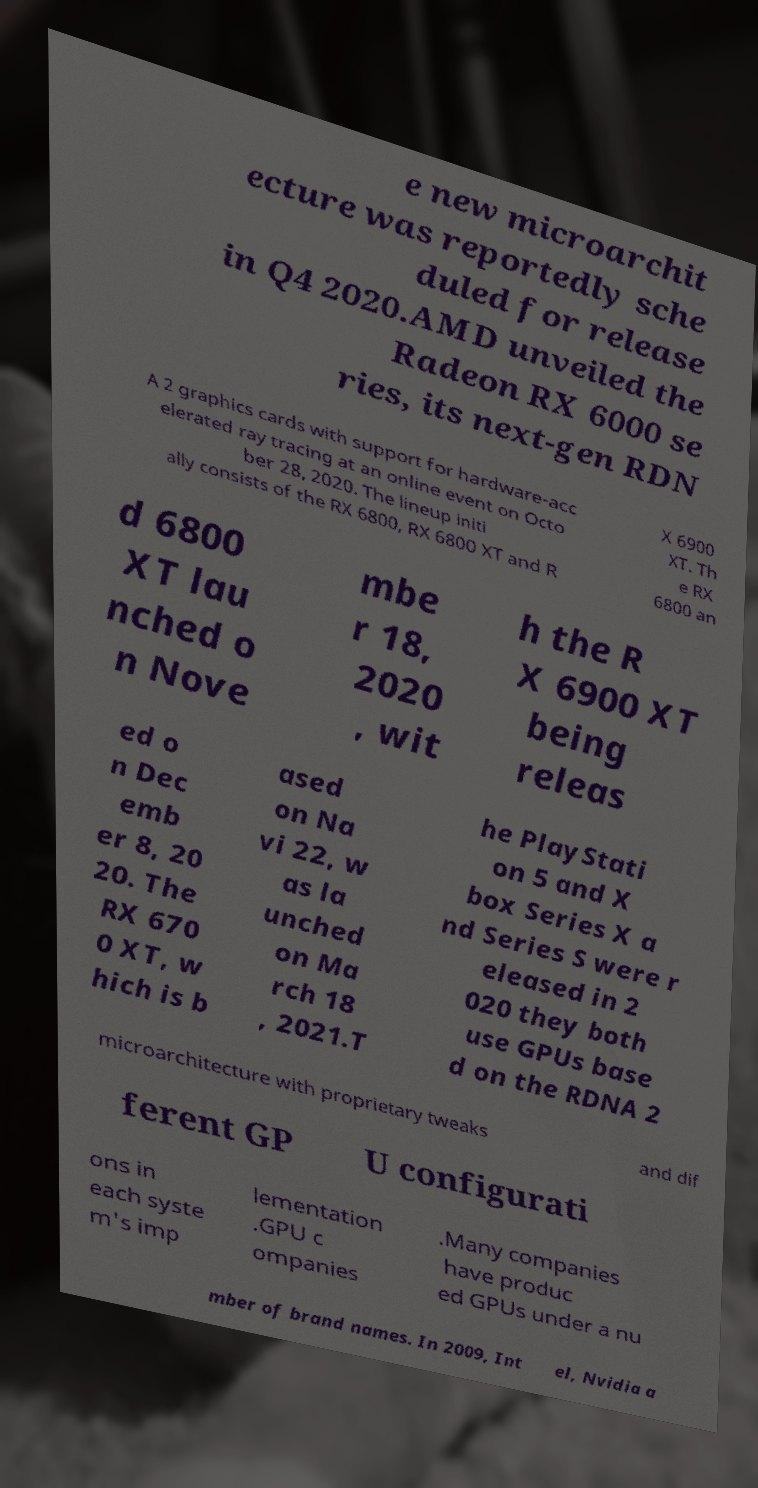What messages or text are displayed in this image? I need them in a readable, typed format. e new microarchit ecture was reportedly sche duled for release in Q4 2020.AMD unveiled the Radeon RX 6000 se ries, its next-gen RDN A 2 graphics cards with support for hardware-acc elerated ray tracing at an online event on Octo ber 28, 2020. The lineup initi ally consists of the RX 6800, RX 6800 XT and R X 6900 XT. Th e RX 6800 an d 6800 XT lau nched o n Nove mbe r 18, 2020 , wit h the R X 6900 XT being releas ed o n Dec emb er 8, 20 20. The RX 670 0 XT, w hich is b ased on Na vi 22, w as la unched on Ma rch 18 , 2021.T he PlayStati on 5 and X box Series X a nd Series S were r eleased in 2 020 they both use GPUs base d on the RDNA 2 microarchitecture with proprietary tweaks and dif ferent GP U configurati ons in each syste m's imp lementation .GPU c ompanies .Many companies have produc ed GPUs under a nu mber of brand names. In 2009, Int el, Nvidia a 